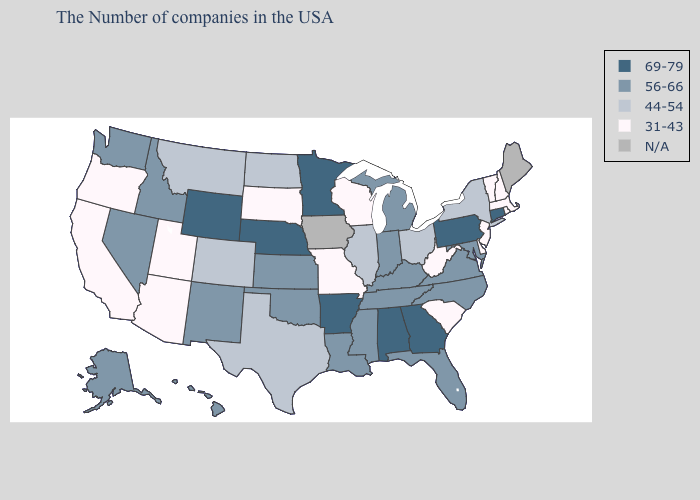Does the first symbol in the legend represent the smallest category?
Write a very short answer. No. Name the states that have a value in the range 56-66?
Quick response, please. Maryland, Virginia, North Carolina, Florida, Michigan, Kentucky, Indiana, Tennessee, Mississippi, Louisiana, Kansas, Oklahoma, New Mexico, Idaho, Nevada, Washington, Alaska, Hawaii. What is the value of North Dakota?
Answer briefly. 44-54. Does the first symbol in the legend represent the smallest category?
Keep it brief. No. Name the states that have a value in the range 69-79?
Short answer required. Connecticut, Pennsylvania, Georgia, Alabama, Arkansas, Minnesota, Nebraska, Wyoming. Which states have the lowest value in the USA?
Give a very brief answer. Massachusetts, Rhode Island, New Hampshire, Vermont, New Jersey, Delaware, South Carolina, West Virginia, Wisconsin, Missouri, South Dakota, Utah, Arizona, California, Oregon. Name the states that have a value in the range 69-79?
Short answer required. Connecticut, Pennsylvania, Georgia, Alabama, Arkansas, Minnesota, Nebraska, Wyoming. What is the value of Alaska?
Keep it brief. 56-66. Name the states that have a value in the range N/A?
Concise answer only. Maine, Iowa. Does the first symbol in the legend represent the smallest category?
Quick response, please. No. Does Alabama have the highest value in the USA?
Short answer required. Yes. Among the states that border North Carolina , does Virginia have the lowest value?
Answer briefly. No. Name the states that have a value in the range 44-54?
Short answer required. New York, Ohio, Illinois, Texas, North Dakota, Colorado, Montana. What is the value of Connecticut?
Quick response, please. 69-79. 